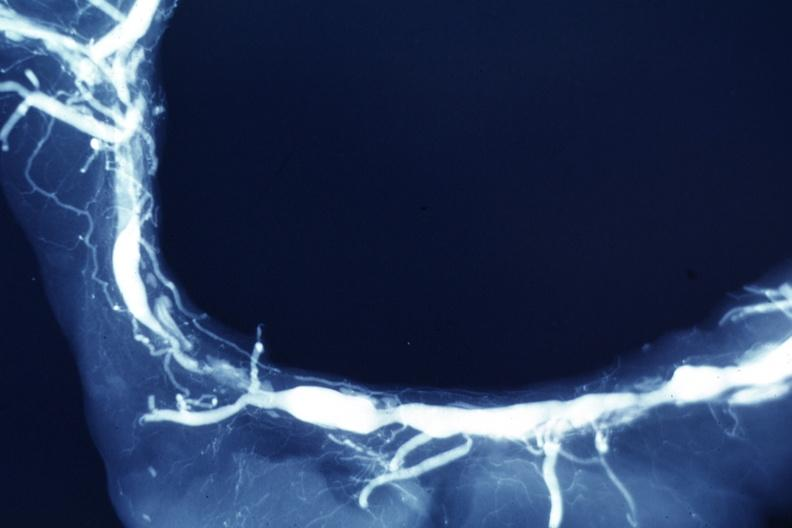does atrophy show x-ray postmortclose-up view of artery with extensive lesions very good example?
Answer the question using a single word or phrase. No 